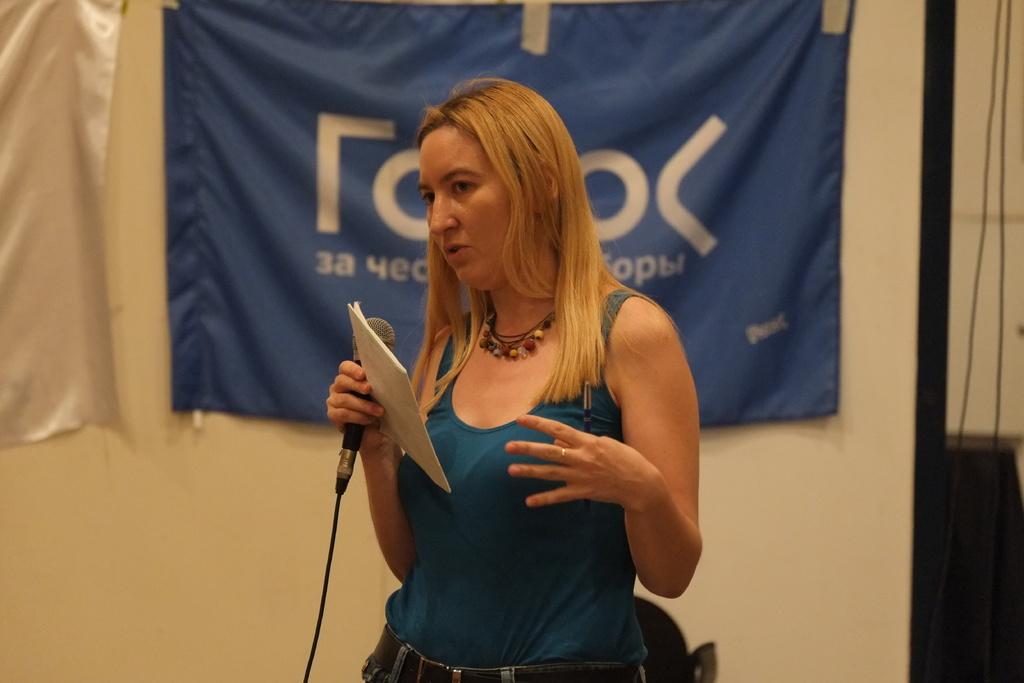In one or two sentences, can you explain what this image depicts? a person is standing holding a book and a microphone in her hand and a pen in the other hand. behind her there are flags. 